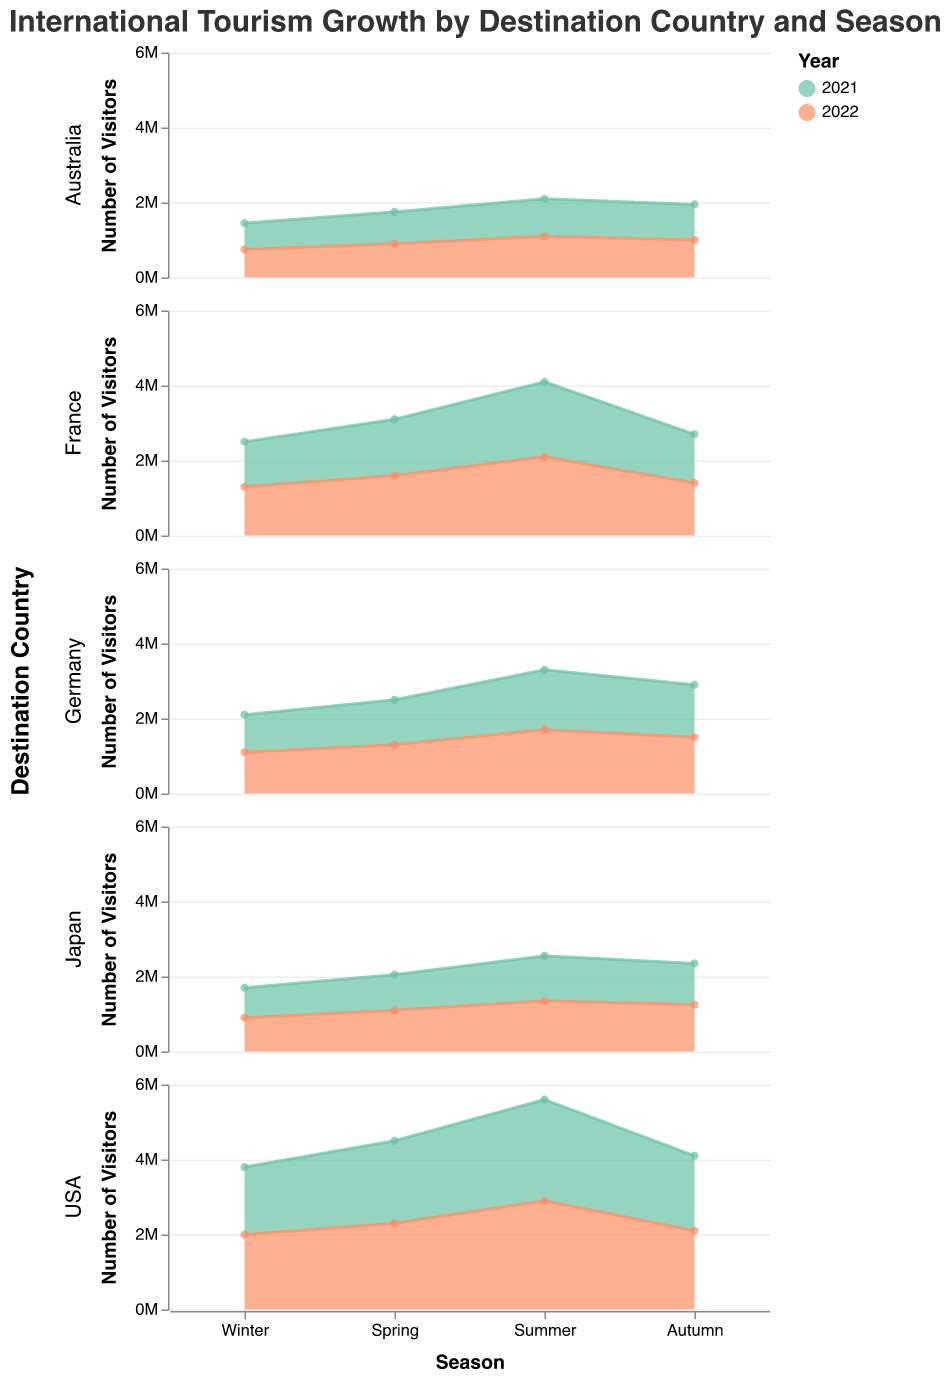How many visitors did Japan have in the summer of 2022? Look at the subplot for Japan and locate the data point for Summer 2022. The tooltip shows 1,350,000 visitors.
Answer: 1,350,000 Which country had the highest number of visitors in Summer 2021? Compare the peak values in the Summer 2021 data points across all subplots. The highest value is 2,700,000 visitors in the USA.
Answer: USA What is the total number of visitors to France in 2022? Add the visitors for France in each season of 2022. 1,300,000 (Winter) + 1,600,000 (Spring) + 2,100,000 (Summer) + 1,400,000 (Autumn) = 6,400,000.
Answer: 6,400,000 Which season had the lowest number of visitors for Australia in 2021? Compare the visitor numbers for each season in 2021 for the Australia subplot. The lowest is Winter with 700,000 visitors.
Answer: Winter What is the trend of visitors in Germany from Winter 2021 to Winter 2022? Observe the Germany subplot. In Winter 2021, there were 1,000,000 visitors. This increased to 1,100,000 in Winter 2022, indicating an upward trend.
Answer: Upward How did the number of visitors in Autumn 2022 compare between France and Germany? Find the data points for Autumn 2022 in the France and Germany subplots. France had 1,400,000 visitors, and Germany had 1,500,000 visitors.
Answer: Germany had more visitors What was the average number of visitors for the USA in 2021? Add the visitors across all seasons in 2021 for the USA and divide by 4. (1,800,000 + 2,200,000 + 2,700,000 + 2,000,000) / 4 = 2,175,000.
Answer: 2,175,000 Which country has the most consistent number of visitors across different seasons in 2022? Evaluate the variability in the visitor numbers in 2022 for each country. Japan shows consistent growth, while others have more significant seasonal variation.
Answer: Japan How did the visitors in Spring 2021 compare to Spring 2022 for Germany? Look at the Germany subplot and compare the visitor numbers. Spring 2021 had 1,200,000 visitors, and Spring 2022 had 1,300,000 visitors.
Answer: Increased by 100,000 Identify the country with the biggest increase in visitors from Summer 2021 to Summer 2022. Evaluate the increase in visitor numbers by comparing Summer 2021 and Summer 2022 across all subplots. The USA had the largest increase, from 2,700,000 to 2,900,000 (an increase of 200,000).
Answer: USA 